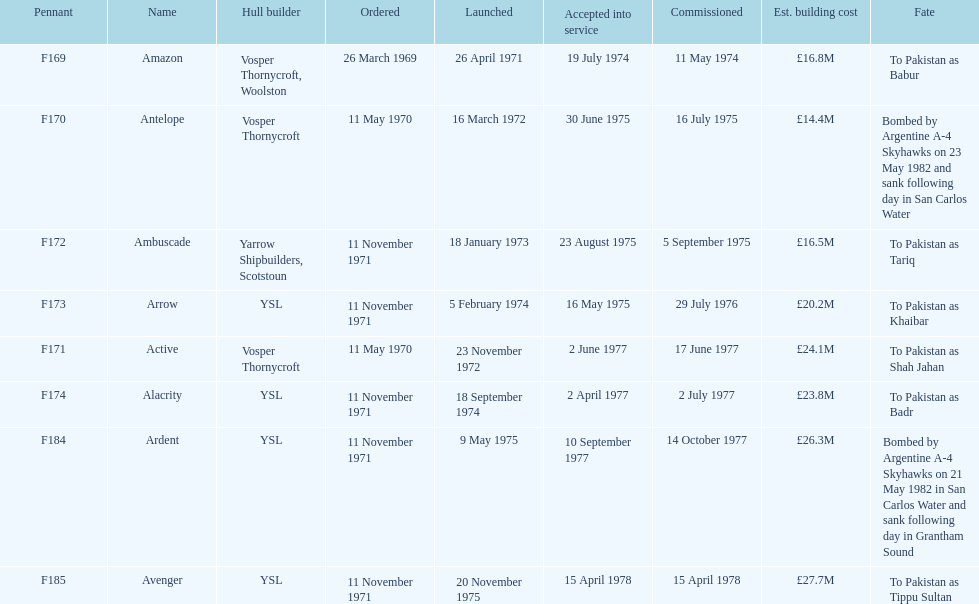Which ships cost more than ps25.0m to build? Ardent, Avenger. Of the ships listed in the answer above, which one cost the most to build? Avenger. 